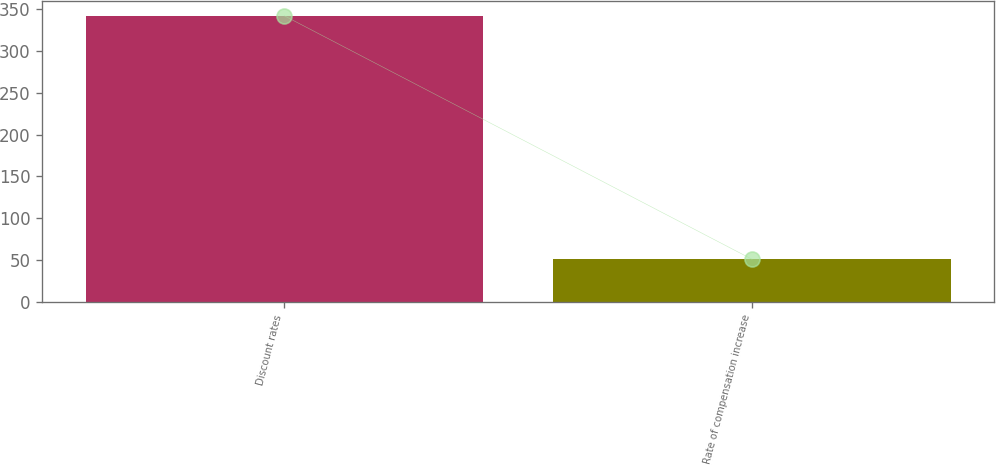<chart> <loc_0><loc_0><loc_500><loc_500><bar_chart><fcel>Discount rates<fcel>Rate of compensation increase<nl><fcel>342<fcel>51<nl></chart> 